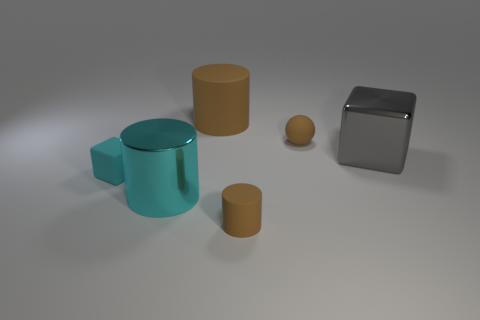Subtract all purple cubes. How many brown cylinders are left? 2 Subtract all brown matte cylinders. How many cylinders are left? 1 Add 3 brown matte things. How many objects exist? 9 Subtract all blocks. How many objects are left? 4 Add 5 small brown rubber objects. How many small brown rubber objects are left? 7 Add 4 large cyan metal cylinders. How many large cyan metal cylinders exist? 5 Subtract 0 gray balls. How many objects are left? 6 Subtract all tiny things. Subtract all small red metallic cylinders. How many objects are left? 3 